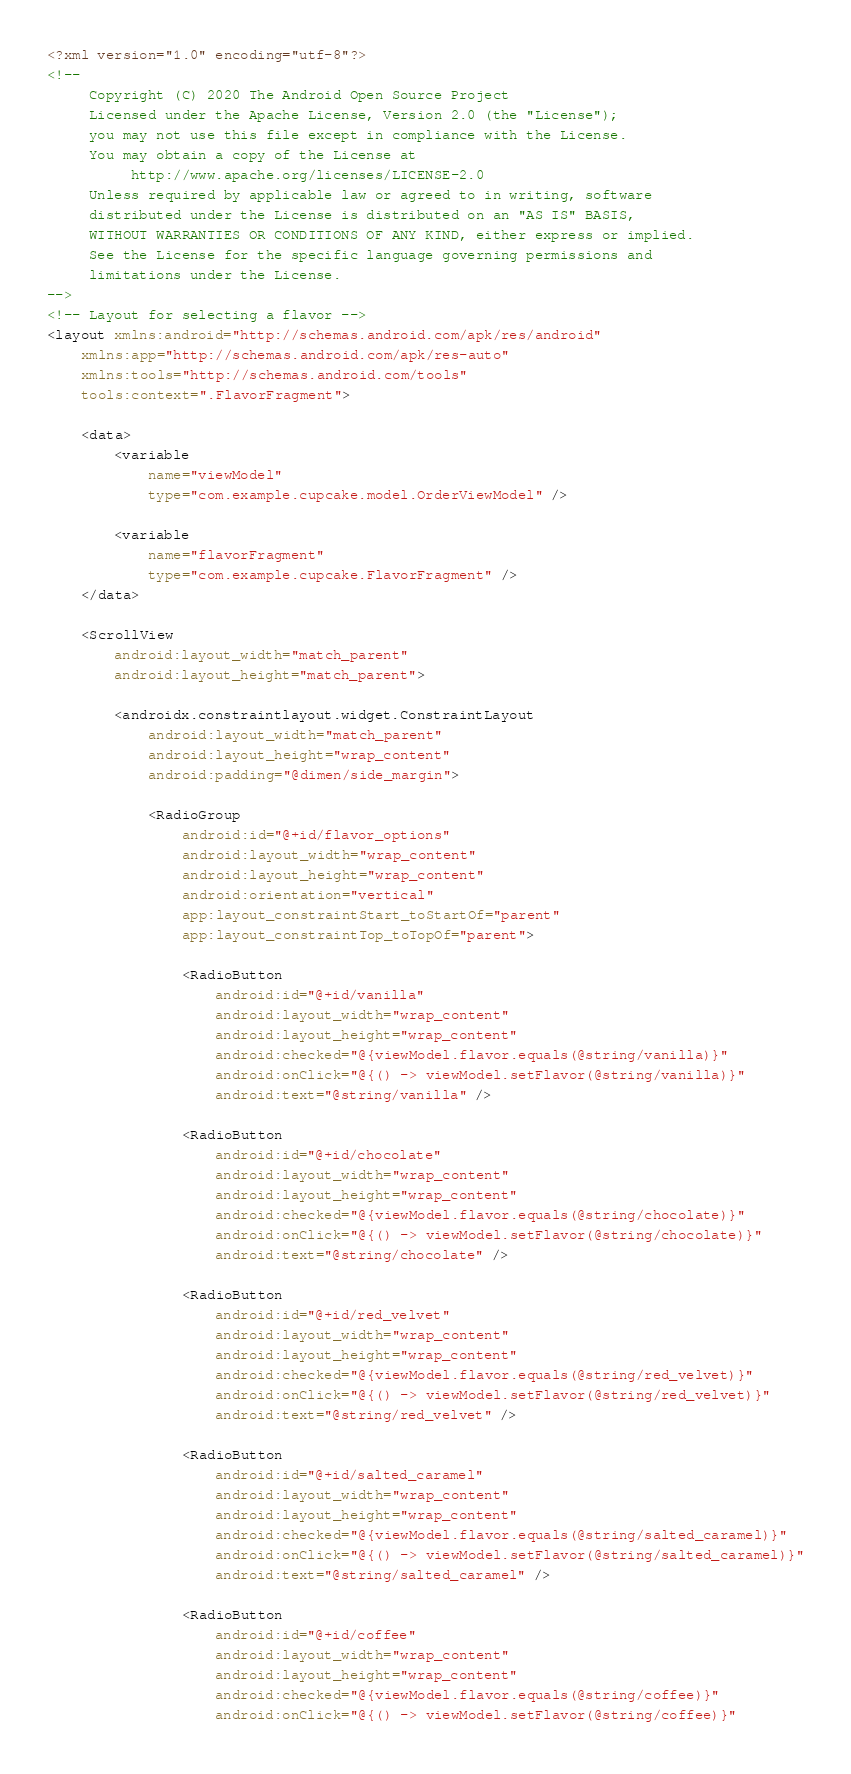<code> <loc_0><loc_0><loc_500><loc_500><_XML_><?xml version="1.0" encoding="utf-8"?>
<!--
     Copyright (C) 2020 The Android Open Source Project
     Licensed under the Apache License, Version 2.0 (the "License");
     you may not use this file except in compliance with the License.
     You may obtain a copy of the License at
          http://www.apache.org/licenses/LICENSE-2.0
     Unless required by applicable law or agreed to in writing, software
     distributed under the License is distributed on an "AS IS" BASIS,
     WITHOUT WARRANTIES OR CONDITIONS OF ANY KIND, either express or implied.
     See the License for the specific language governing permissions and
     limitations under the License.
-->
<!-- Layout for selecting a flavor -->
<layout xmlns:android="http://schemas.android.com/apk/res/android"
    xmlns:app="http://schemas.android.com/apk/res-auto"
    xmlns:tools="http://schemas.android.com/tools"
    tools:context=".FlavorFragment">

    <data>
        <variable
            name="viewModel"
            type="com.example.cupcake.model.OrderViewModel" />

        <variable
            name="flavorFragment"
            type="com.example.cupcake.FlavorFragment" />
    </data>

    <ScrollView
        android:layout_width="match_parent"
        android:layout_height="match_parent">

        <androidx.constraintlayout.widget.ConstraintLayout
            android:layout_width="match_parent"
            android:layout_height="wrap_content"
            android:padding="@dimen/side_margin">

            <RadioGroup
                android:id="@+id/flavor_options"
                android:layout_width="wrap_content"
                android:layout_height="wrap_content"
                android:orientation="vertical"
                app:layout_constraintStart_toStartOf="parent"
                app:layout_constraintTop_toTopOf="parent">

                <RadioButton
                    android:id="@+id/vanilla"
                    android:layout_width="wrap_content"
                    android:layout_height="wrap_content"
                    android:checked="@{viewModel.flavor.equals(@string/vanilla)}"
                    android:onClick="@{() -> viewModel.setFlavor(@string/vanilla)}"
                    android:text="@string/vanilla" />

                <RadioButton
                    android:id="@+id/chocolate"
                    android:layout_width="wrap_content"
                    android:layout_height="wrap_content"
                    android:checked="@{viewModel.flavor.equals(@string/chocolate)}"
                    android:onClick="@{() -> viewModel.setFlavor(@string/chocolate)}"
                    android:text="@string/chocolate" />

                <RadioButton
                    android:id="@+id/red_velvet"
                    android:layout_width="wrap_content"
                    android:layout_height="wrap_content"
                    android:checked="@{viewModel.flavor.equals(@string/red_velvet)}"
                    android:onClick="@{() -> viewModel.setFlavor(@string/red_velvet)}"
                    android:text="@string/red_velvet" />

                <RadioButton
                    android:id="@+id/salted_caramel"
                    android:layout_width="wrap_content"
                    android:layout_height="wrap_content"
                    android:checked="@{viewModel.flavor.equals(@string/salted_caramel)}"
                    android:onClick="@{() -> viewModel.setFlavor(@string/salted_caramel)}"
                    android:text="@string/salted_caramel" />

                <RadioButton
                    android:id="@+id/coffee"
                    android:layout_width="wrap_content"
                    android:layout_height="wrap_content"
                    android:checked="@{viewModel.flavor.equals(@string/coffee)}"
                    android:onClick="@{() -> viewModel.setFlavor(@string/coffee)}"</code> 